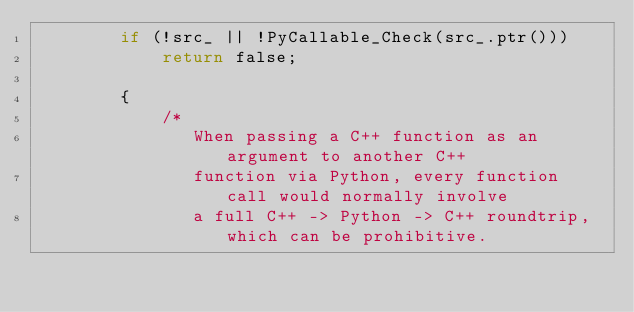Convert code to text. <code><loc_0><loc_0><loc_500><loc_500><_C_>        if (!src_ || !PyCallable_Check(src_.ptr()))
            return false;

        {
            /*
               When passing a C++ function as an argument to another C++
               function via Python, every function call would normally involve
               a full C++ -> Python -> C++ roundtrip, which can be prohibitive.</code> 